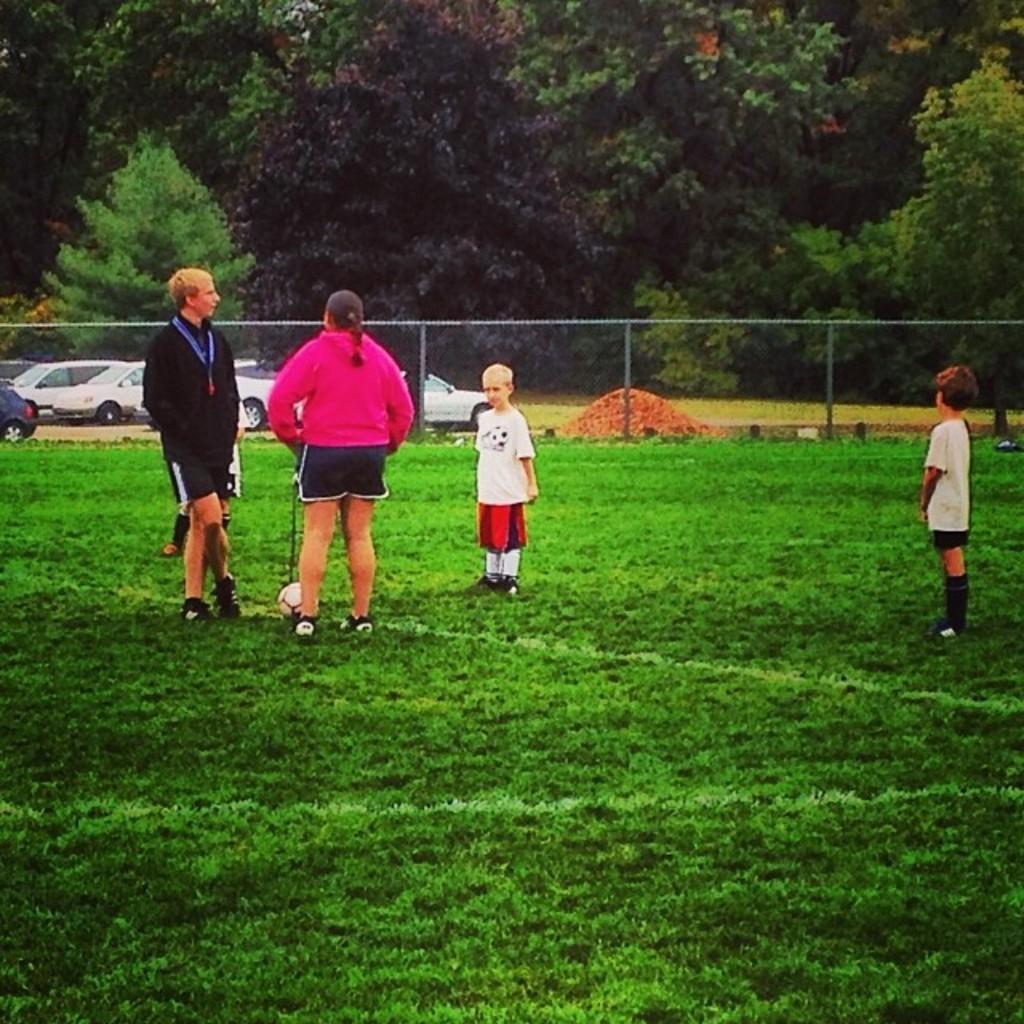Can you describe this image briefly? In this image I can see the group of people standing. In front the person is wearing pink and black color dress. In the background I can see the railing, few vehicles and few trees in green color. 